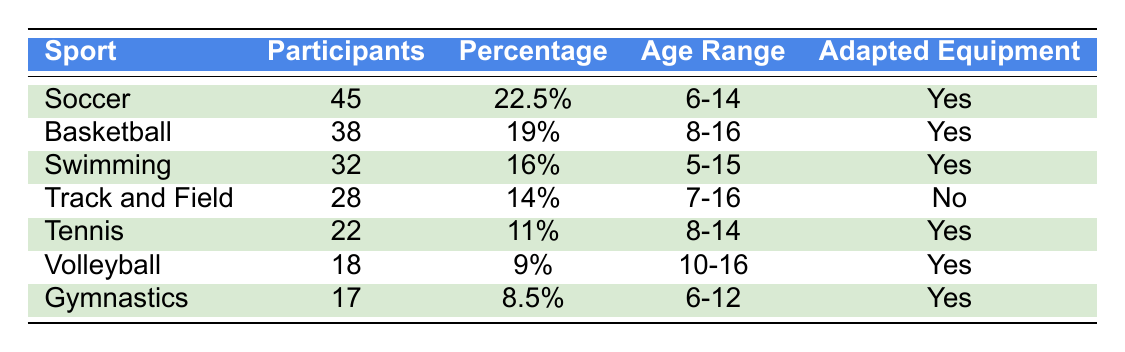What sport has the highest number of participants? By examining the "Number of Participants" column, we see that Soccer has 45 participants, which is more than any other sport listed.
Answer: Soccer What percentage of total participants does Basketball account for? The table shows that Basketball has a percentage of 19%.
Answer: 19% How many participants are involved in Tennis? The table indicates that the number of participants in Tennis is 22.
Answer: 22 Is adapted equipment used in Volleyball? According to the "Adapted Equipment Used" column, Volleyball does use adapted equipment, as it states "Yes."
Answer: Yes Which sport has the lowest number of participants? Looking at the "Number of Participants" column, Gymnastics has the lowest count with 17 participants.
Answer: Gymnastics What is the total number of participants across all sports? To find the total, we add up all participants: 45 + 38 + 32 + 28 + 22 + 18 + 17 = 200.
Answer: 200 What is the average percentage of total participation for all sports? We sum the percentages: 22.5 + 19 + 16 + 14 + 11 + 9 + 8.5 = 100, then divide by 7 (the number of sports): 100 / 7 ≈ 14.29.
Answer: 14.29% Does Soccer use adapted equipment? The table clearly shows "Yes" in the "Adapted Equipment Used" column for Soccer.
Answer: Yes What age range is covered by Swimming participants? The age range specified for Swimming in the table is 5-15 years.
Answer: 5-15 What sport has the largest age range? By reviewing the age ranges listed, Track and Field (7-16) has the largest range from 7 to 16 years.
Answer: Track and Field 